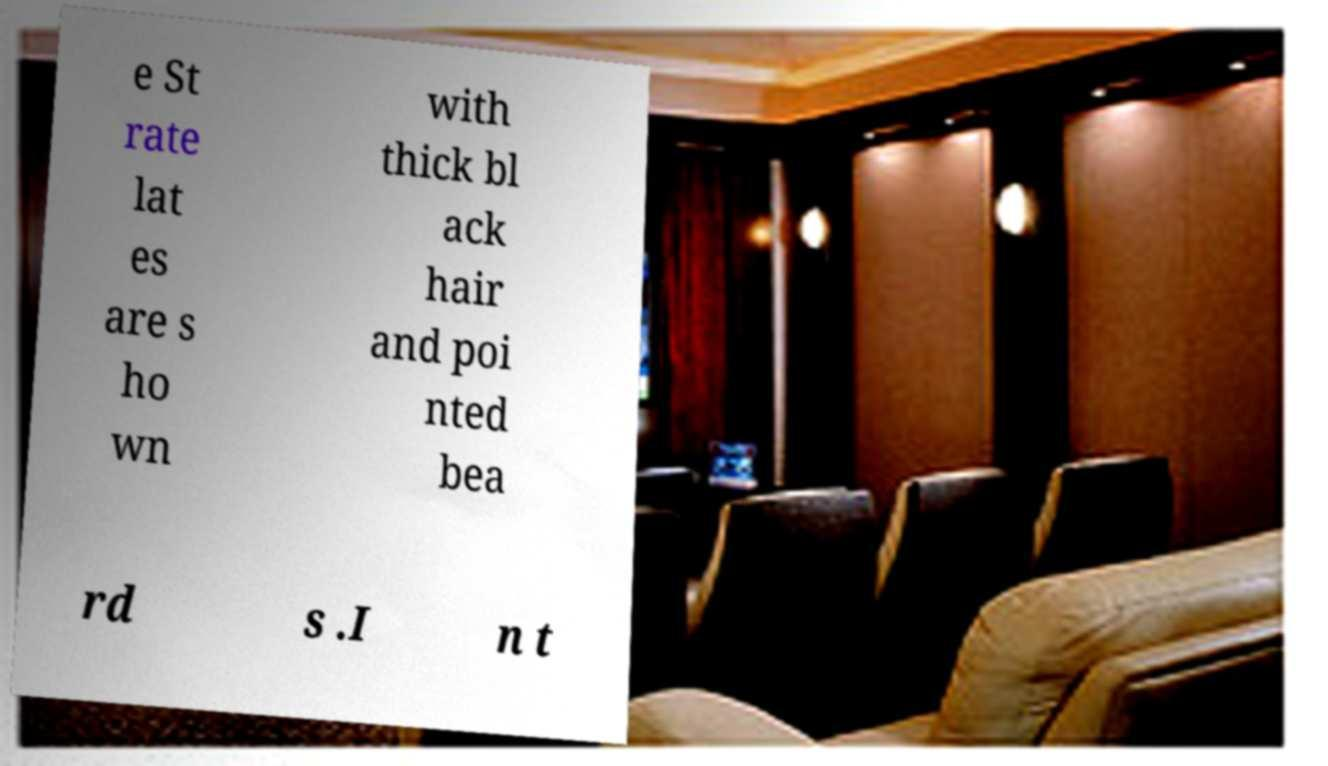Please read and relay the text visible in this image. What does it say? e St rate lat es are s ho wn with thick bl ack hair and poi nted bea rd s .I n t 